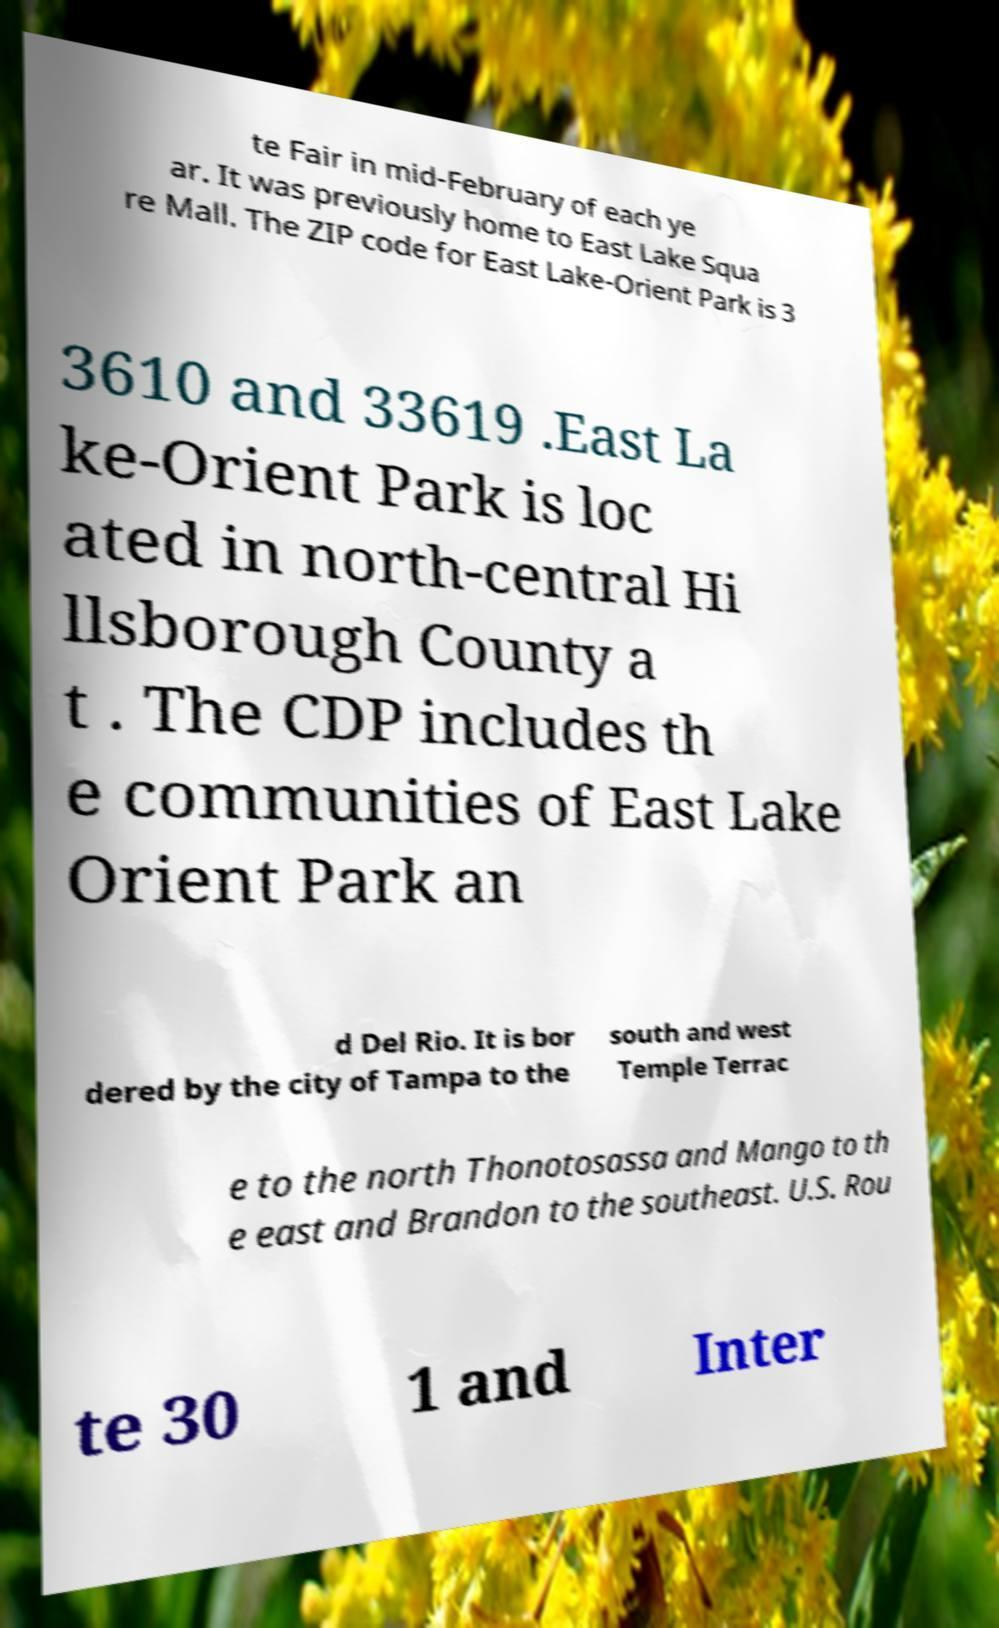What messages or text are displayed in this image? I need them in a readable, typed format. te Fair in mid-February of each ye ar. It was previously home to East Lake Squa re Mall. The ZIP code for East Lake-Orient Park is 3 3610 and 33619 .East La ke-Orient Park is loc ated in north-central Hi llsborough County a t . The CDP includes th e communities of East Lake Orient Park an d Del Rio. It is bor dered by the city of Tampa to the south and west Temple Terrac e to the north Thonotosassa and Mango to th e east and Brandon to the southeast. U.S. Rou te 30 1 and Inter 